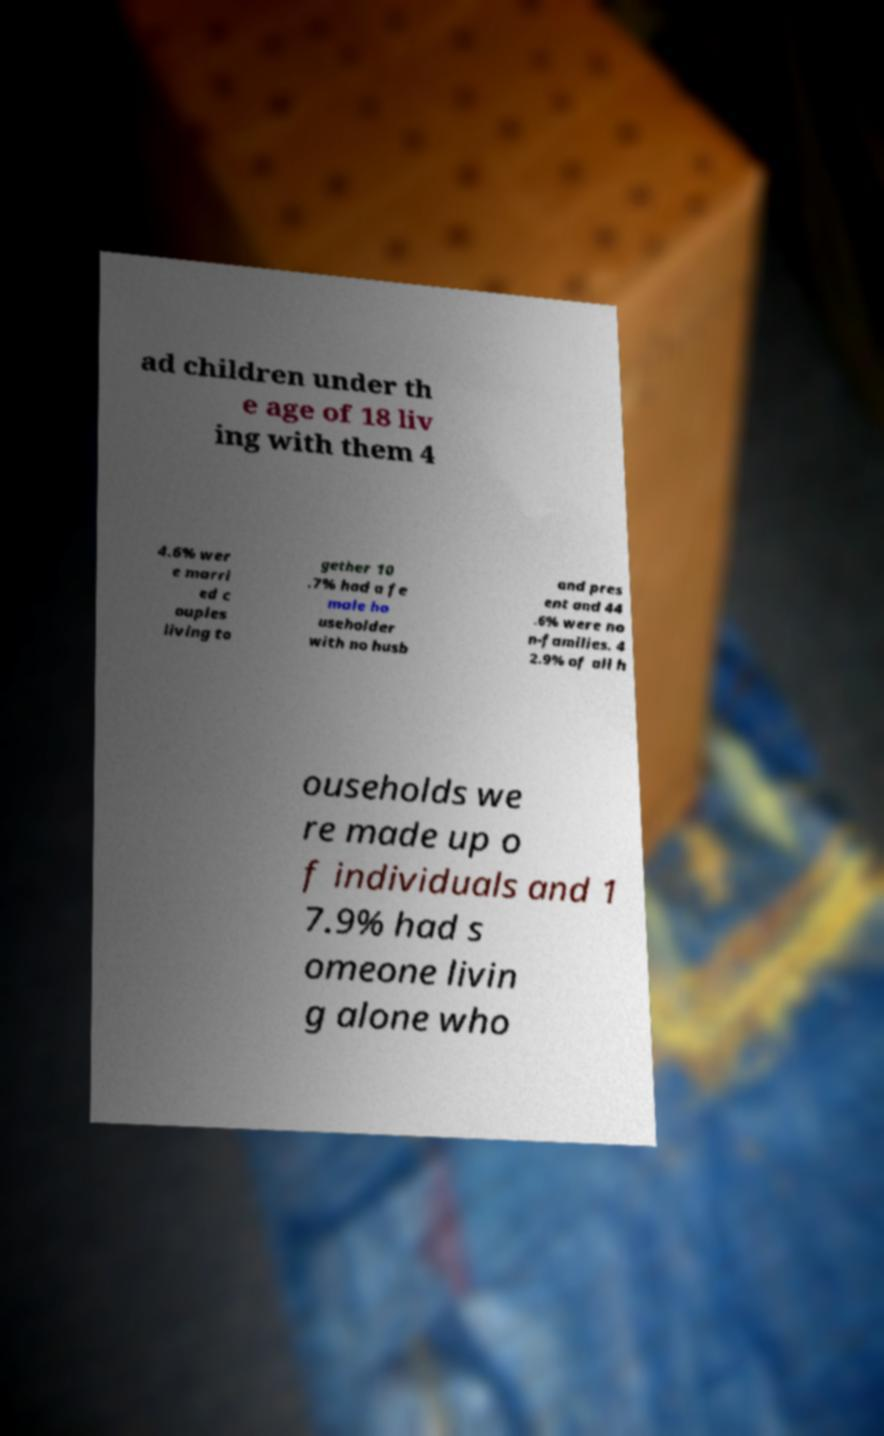I need the written content from this picture converted into text. Can you do that? ad children under th e age of 18 liv ing with them 4 4.6% wer e marri ed c ouples living to gether 10 .7% had a fe male ho useholder with no husb and pres ent and 44 .6% were no n-families. 4 2.9% of all h ouseholds we re made up o f individuals and 1 7.9% had s omeone livin g alone who 